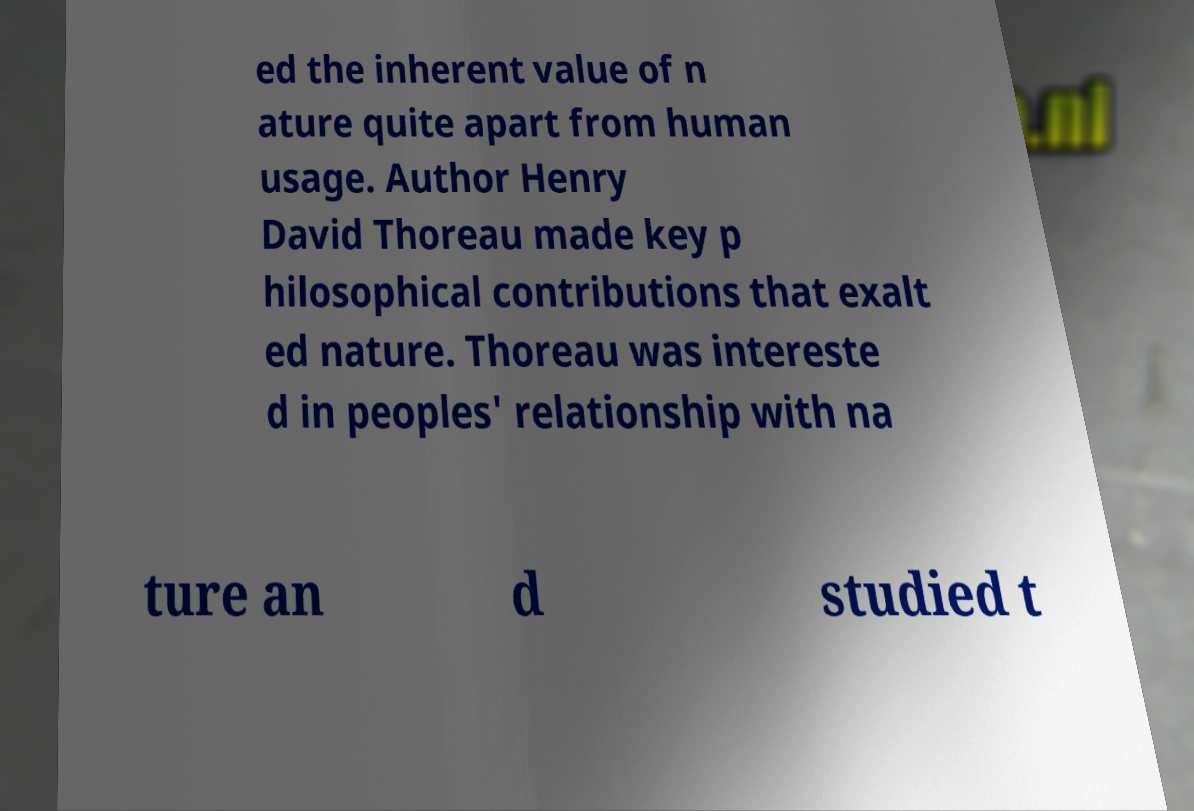Can you accurately transcribe the text from the provided image for me? ed the inherent value of n ature quite apart from human usage. Author Henry David Thoreau made key p hilosophical contributions that exalt ed nature. Thoreau was intereste d in peoples' relationship with na ture an d studied t 